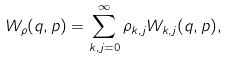Convert formula to latex. <formula><loc_0><loc_0><loc_500><loc_500>W _ { \rho } ( q , p ) = \sum _ { k , j = 0 } ^ { \infty } \rho _ { k , j } W _ { k , j } ( q , p ) ,</formula> 